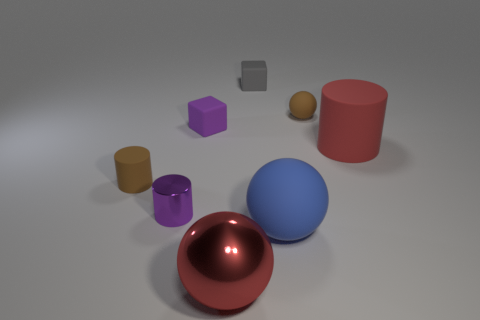Add 1 purple rubber objects. How many objects exist? 9 Subtract all big shiny balls. How many balls are left? 2 Subtract all cylinders. How many objects are left? 5 Subtract all brown cylinders. How many cylinders are left? 2 Subtract all green cubes. Subtract all green balls. How many cubes are left? 2 Subtract all tiny gray cubes. Subtract all small matte cylinders. How many objects are left? 6 Add 6 large red cylinders. How many large red cylinders are left? 7 Add 3 large cylinders. How many large cylinders exist? 4 Subtract 1 brown cylinders. How many objects are left? 7 